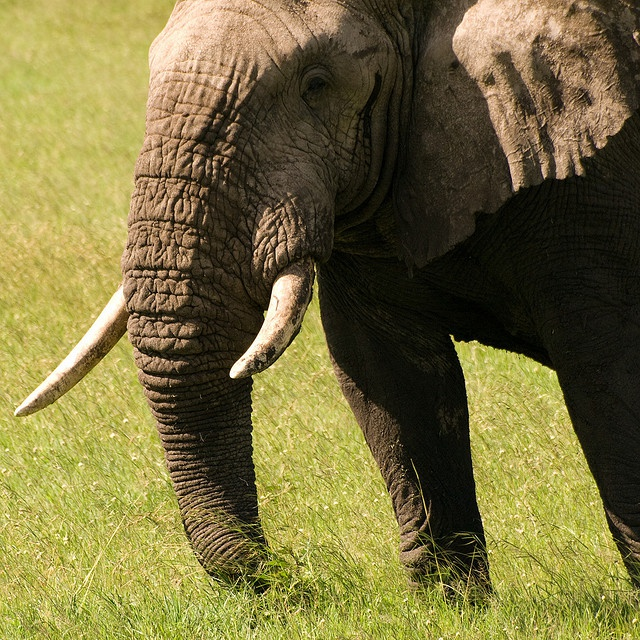Describe the objects in this image and their specific colors. I can see a elephant in tan, black, and olive tones in this image. 